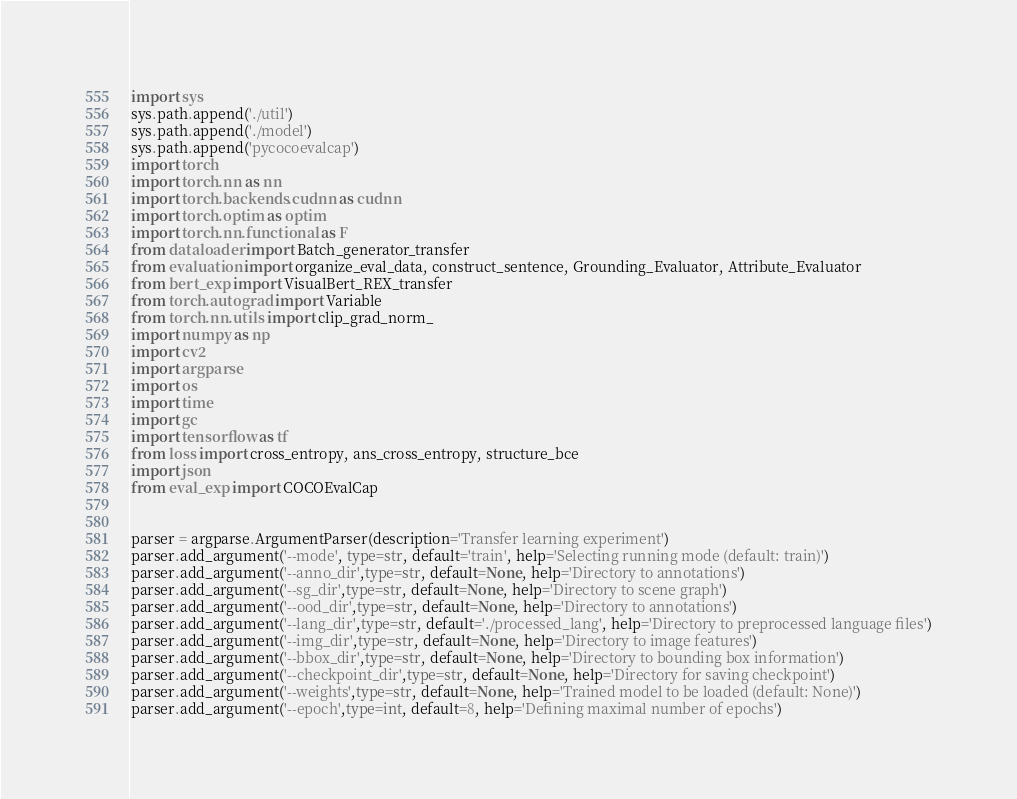<code> <loc_0><loc_0><loc_500><loc_500><_Python_>import sys
sys.path.append('./util')
sys.path.append('./model')
sys.path.append('pycocoevalcap')
import torch
import torch.nn as nn
import torch.backends.cudnn as cudnn
import torch.optim as optim
import torch.nn.functional as F
from dataloader import Batch_generator_transfer
from evaluation import organize_eval_data, construct_sentence, Grounding_Evaluator, Attribute_Evaluator
from bert_exp import VisualBert_REX_transfer
from torch.autograd import Variable
from torch.nn.utils import clip_grad_norm_
import numpy as np
import cv2
import argparse
import os
import time
import gc
import tensorflow as tf
from loss import cross_entropy, ans_cross_entropy, structure_bce
import json
from eval_exp import COCOEvalCap


parser = argparse.ArgumentParser(description='Transfer learning experiment')
parser.add_argument('--mode', type=str, default='train', help='Selecting running mode (default: train)')
parser.add_argument('--anno_dir',type=str, default=None, help='Directory to annotations')
parser.add_argument('--sg_dir',type=str, default=None, help='Directory to scene graph')
parser.add_argument('--ood_dir',type=str, default=None, help='Directory to annotations')
parser.add_argument('--lang_dir',type=str, default='./processed_lang', help='Directory to preprocessed language files')
parser.add_argument('--img_dir',type=str, default=None, help='Directory to image features')
parser.add_argument('--bbox_dir',type=str, default=None, help='Directory to bounding box information')
parser.add_argument('--checkpoint_dir',type=str, default=None, help='Directory for saving checkpoint')
parser.add_argument('--weights',type=str, default=None, help='Trained model to be loaded (default: None)')
parser.add_argument('--epoch',type=int, default=8, help='Defining maximal number of epochs')</code> 